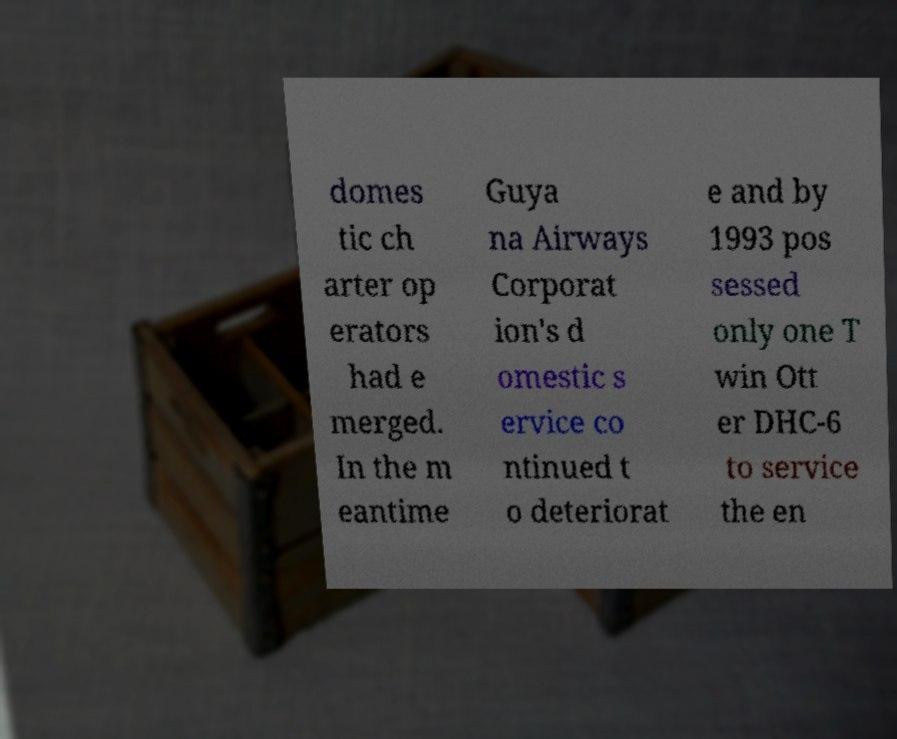For documentation purposes, I need the text within this image transcribed. Could you provide that? domes tic ch arter op erators had e merged. In the m eantime Guya na Airways Corporat ion's d omestic s ervice co ntinued t o deteriorat e and by 1993 pos sessed only one T win Ott er DHC-6 to service the en 